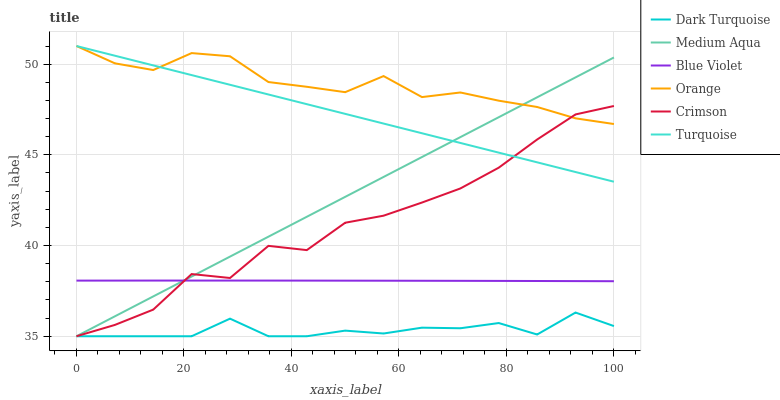Does Dark Turquoise have the minimum area under the curve?
Answer yes or no. Yes. Does Orange have the maximum area under the curve?
Answer yes or no. Yes. Does Crimson have the minimum area under the curve?
Answer yes or no. No. Does Crimson have the maximum area under the curve?
Answer yes or no. No. Is Medium Aqua the smoothest?
Answer yes or no. Yes. Is Crimson the roughest?
Answer yes or no. Yes. Is Dark Turquoise the smoothest?
Answer yes or no. No. Is Dark Turquoise the roughest?
Answer yes or no. No. Does Dark Turquoise have the lowest value?
Answer yes or no. Yes. Does Orange have the lowest value?
Answer yes or no. No. Does Orange have the highest value?
Answer yes or no. Yes. Does Crimson have the highest value?
Answer yes or no. No. Is Dark Turquoise less than Turquoise?
Answer yes or no. Yes. Is Blue Violet greater than Dark Turquoise?
Answer yes or no. Yes. Does Orange intersect Medium Aqua?
Answer yes or no. Yes. Is Orange less than Medium Aqua?
Answer yes or no. No. Is Orange greater than Medium Aqua?
Answer yes or no. No. Does Dark Turquoise intersect Turquoise?
Answer yes or no. No. 